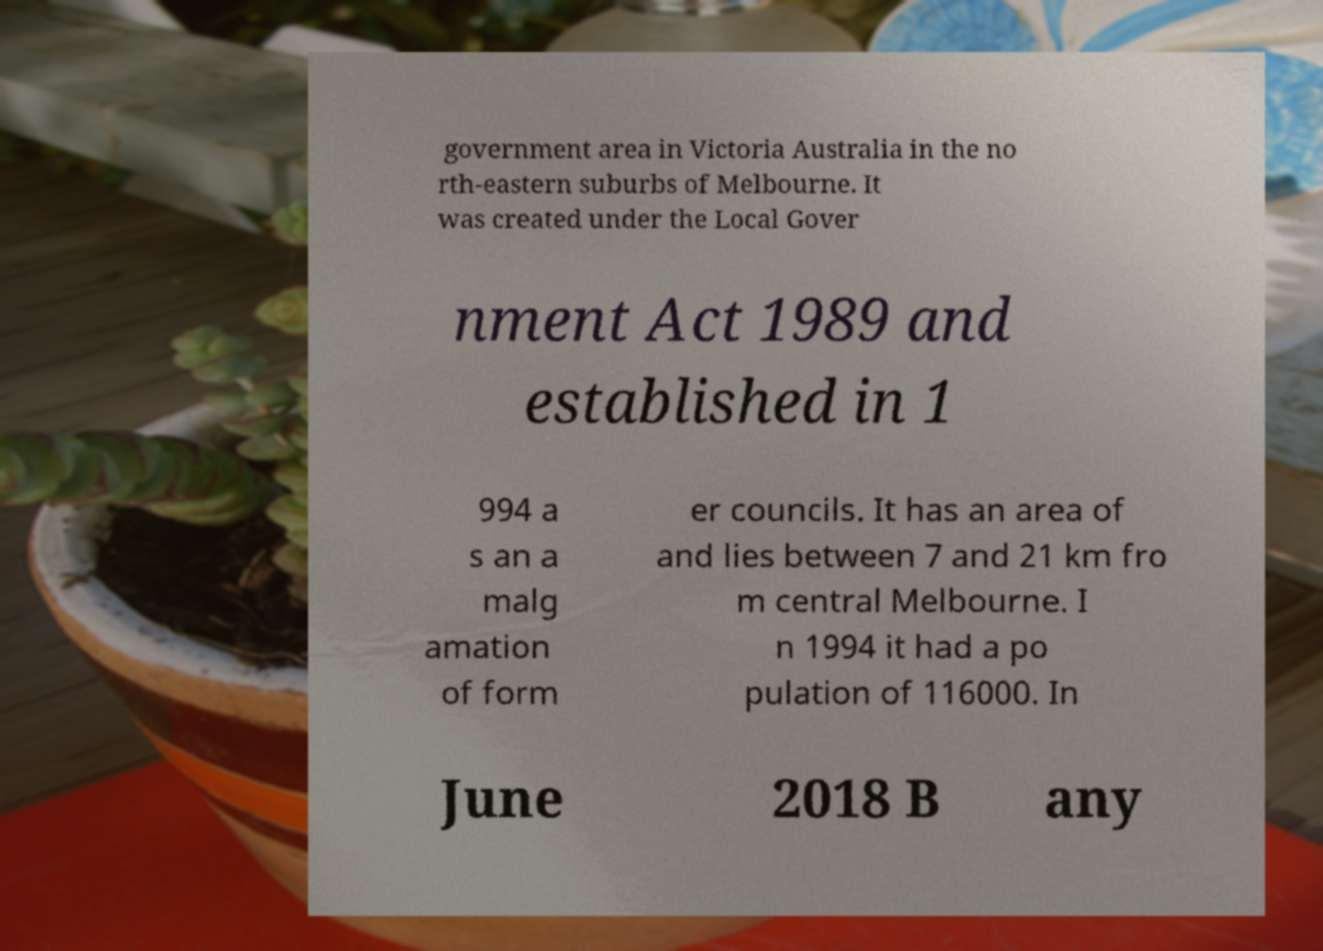Please read and relay the text visible in this image. What does it say? government area in Victoria Australia in the no rth-eastern suburbs of Melbourne. It was created under the Local Gover nment Act 1989 and established in 1 994 a s an a malg amation of form er councils. It has an area of and lies between 7 and 21 km fro m central Melbourne. I n 1994 it had a po pulation of 116000. In June 2018 B any 